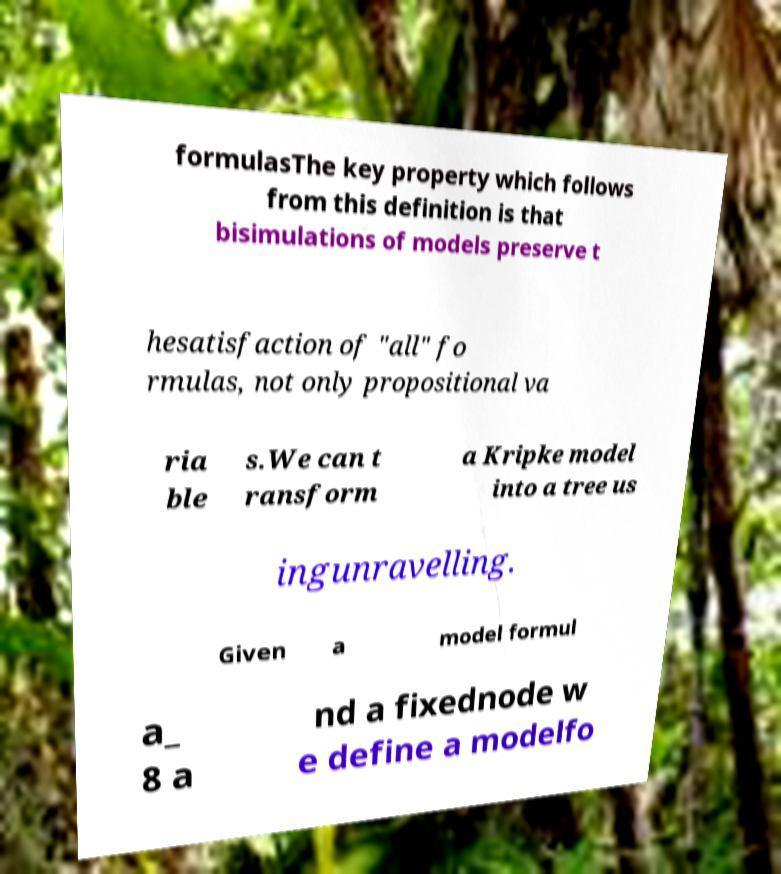For documentation purposes, I need the text within this image transcribed. Could you provide that? formulasThe key property which follows from this definition is that bisimulations of models preserve t hesatisfaction of "all" fo rmulas, not only propositional va ria ble s.We can t ransform a Kripke model into a tree us ingunravelling. Given a model formul a_ 8 a nd a fixednode w e define a modelfo 